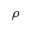<formula> <loc_0><loc_0><loc_500><loc_500>\rho</formula> 